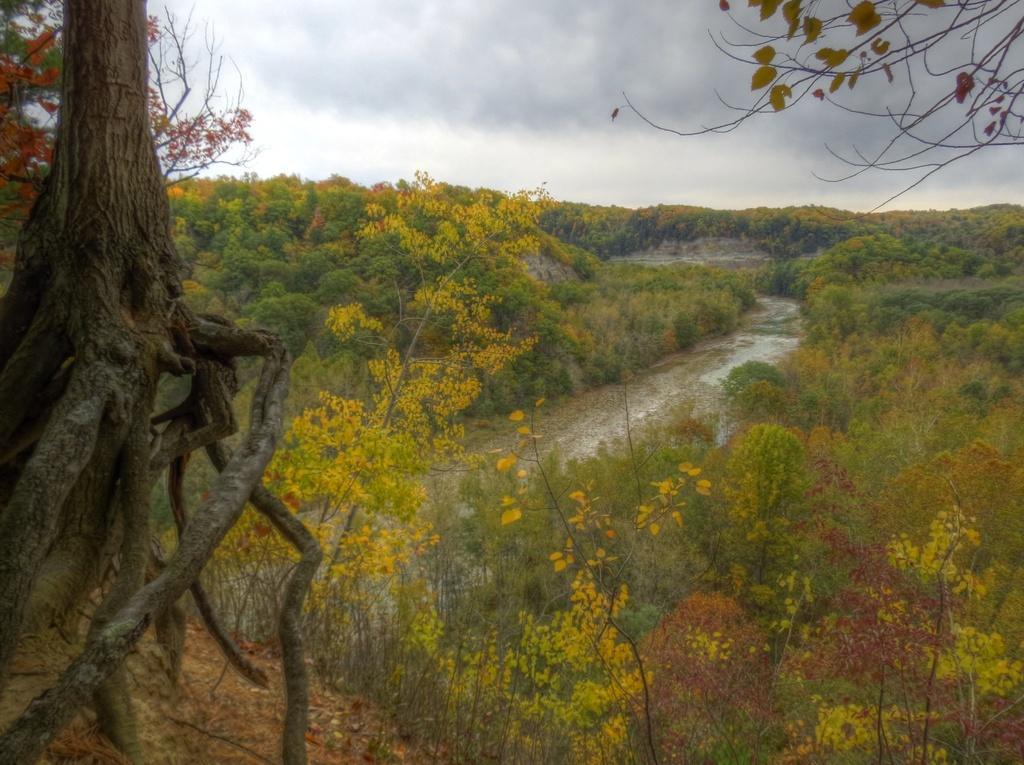Please provide a concise description of this image. In this image I see trees, plants and I see the water over here. In the background I see the sky which is cloudy. 